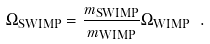Convert formula to latex. <formula><loc_0><loc_0><loc_500><loc_500>\Omega _ { \text {SWIMP} } = \frac { m _ { \text {SWIMP} } } { m _ { \text {WIMP} } } \Omega _ { \text {WIMP} } \ .</formula> 